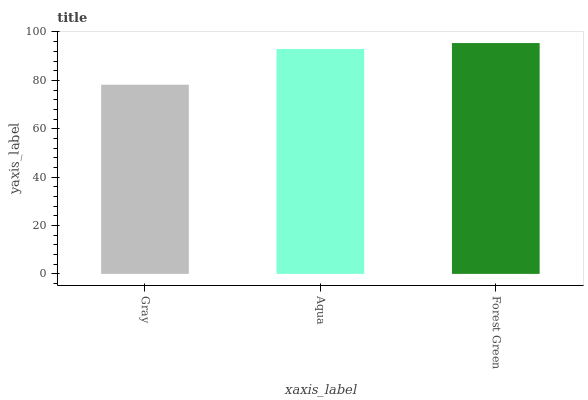Is Gray the minimum?
Answer yes or no. Yes. Is Forest Green the maximum?
Answer yes or no. Yes. Is Aqua the minimum?
Answer yes or no. No. Is Aqua the maximum?
Answer yes or no. No. Is Aqua greater than Gray?
Answer yes or no. Yes. Is Gray less than Aqua?
Answer yes or no. Yes. Is Gray greater than Aqua?
Answer yes or no. No. Is Aqua less than Gray?
Answer yes or no. No. Is Aqua the high median?
Answer yes or no. Yes. Is Aqua the low median?
Answer yes or no. Yes. Is Gray the high median?
Answer yes or no. No. Is Forest Green the low median?
Answer yes or no. No. 